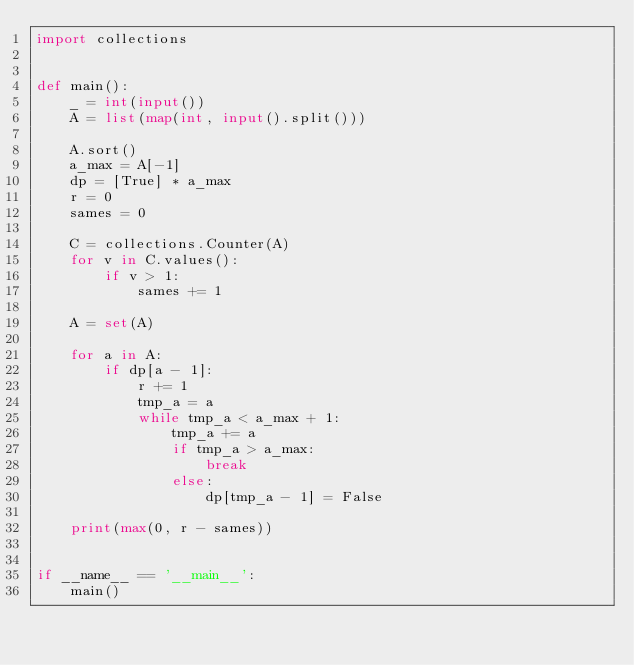Convert code to text. <code><loc_0><loc_0><loc_500><loc_500><_Python_>import collections


def main():
    _ = int(input())
    A = list(map(int, input().split()))

    A.sort()
    a_max = A[-1]
    dp = [True] * a_max
    r = 0
    sames = 0

    C = collections.Counter(A)
    for v in C.values():
        if v > 1:
            sames += 1

    A = set(A)

    for a in A:
        if dp[a - 1]:
            r += 1
            tmp_a = a
            while tmp_a < a_max + 1:
                tmp_a += a
                if tmp_a > a_max:
                    break
                else:
                    dp[tmp_a - 1] = False

    print(max(0, r - sames))


if __name__ == '__main__':
    main()</code> 